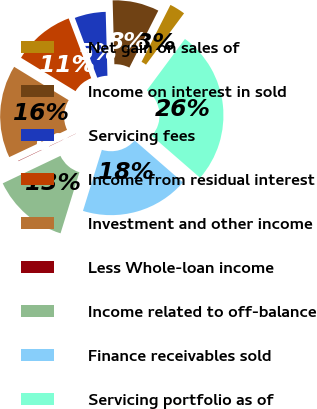Convert chart to OTSL. <chart><loc_0><loc_0><loc_500><loc_500><pie_chart><fcel>Net gain on sales of<fcel>Income on interest in sold<fcel>Servicing fees<fcel>Income from residual interest<fcel>Investment and other income<fcel>Less Whole-loan income<fcel>Income related to off-balance<fcel>Finance receivables sold<fcel>Servicing portfolio as of<nl><fcel>2.68%<fcel>7.91%<fcel>5.29%<fcel>10.53%<fcel>15.76%<fcel>0.06%<fcel>13.15%<fcel>18.38%<fcel>26.23%<nl></chart> 